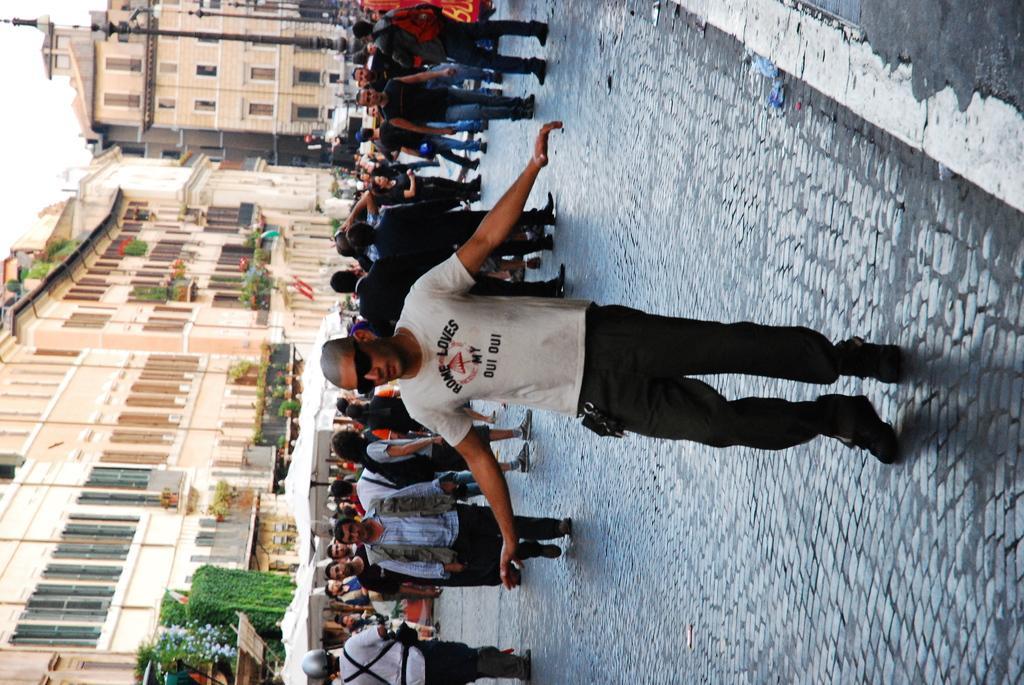In one or two sentences, can you explain what this image depicts? In this image we can see many people, some of them are walking. In the background there are buildings and sky. At the bottom there are bushes. 